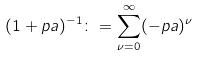Convert formula to latex. <formula><loc_0><loc_0><loc_500><loc_500>( 1 + p a ) ^ { - 1 } \colon = \sum ^ { \infty } _ { \nu = 0 } ( - p a ) ^ { \nu }</formula> 